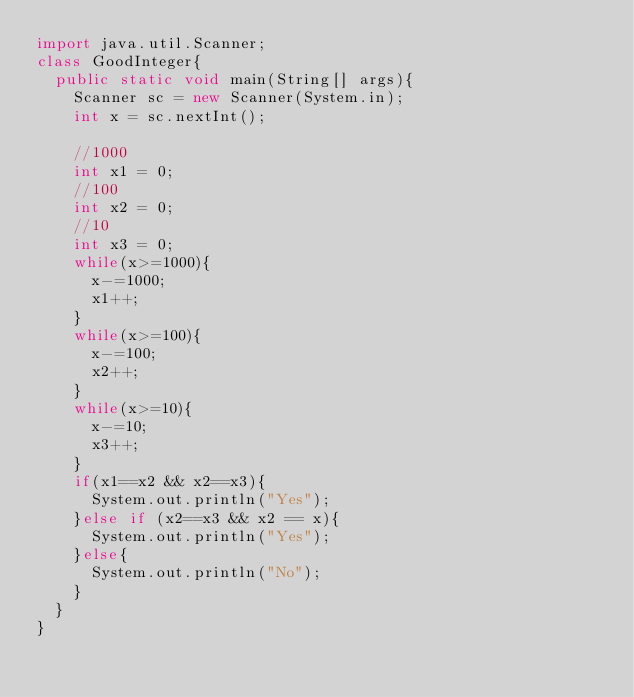<code> <loc_0><loc_0><loc_500><loc_500><_Java_>import java.util.Scanner;
class GoodInteger{
	public static void main(String[] args){
		Scanner sc = new Scanner(System.in);
		int x = sc.nextInt();
		
		//1000
		int x1 = 0;
		//100
		int x2 = 0;
		//10
		int x3 = 0;
		while(x>=1000){
			x-=1000;
			x1++;
		}
		while(x>=100){
			x-=100;
			x2++;
		}
		while(x>=10){
			x-=10;
			x3++;
		}
		if(x1==x2 && x2==x3){
			System.out.println("Yes");
		}else if (x2==x3 && x2 == x){
			System.out.println("Yes");
		}else{
			System.out.println("No");
		}
	}
}
</code> 